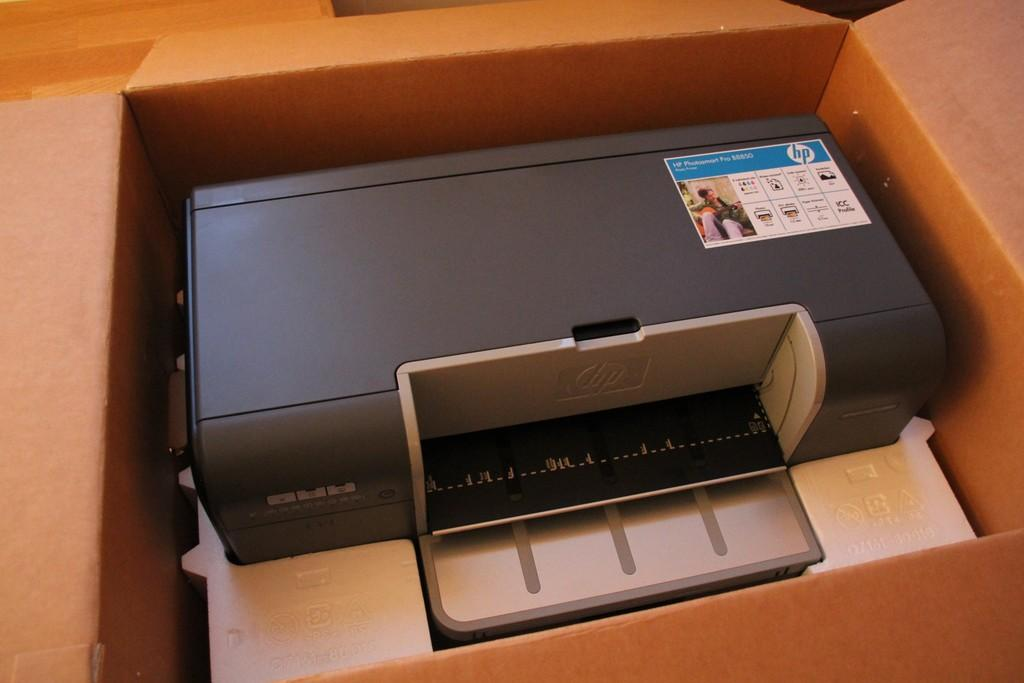<image>
Create a compact narrative representing the image presented. A freshly opened printer that is the brand HP. 